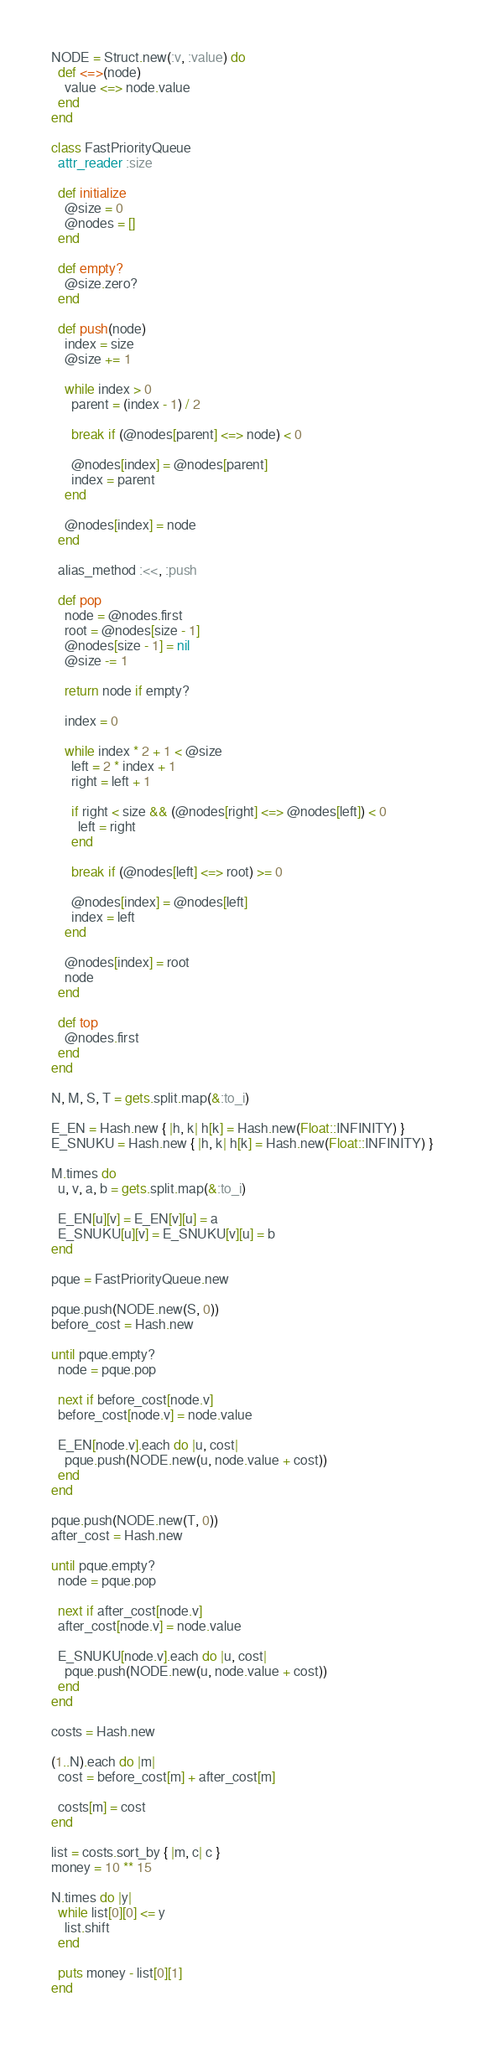<code> <loc_0><loc_0><loc_500><loc_500><_Ruby_>NODE = Struct.new(:v, :value) do
  def <=>(node)
    value <=> node.value
  end
end

class FastPriorityQueue
  attr_reader :size

  def initialize
    @size = 0
    @nodes = []
  end

  def empty?
    @size.zero?
  end

  def push(node)
    index = size
    @size += 1

    while index > 0
      parent = (index - 1) / 2

      break if (@nodes[parent] <=> node) < 0

      @nodes[index] = @nodes[parent]
      index = parent
    end

    @nodes[index] = node
  end

  alias_method :<<, :push

  def pop
    node = @nodes.first
    root = @nodes[size - 1]
    @nodes[size - 1] = nil
    @size -= 1

    return node if empty?

    index = 0

    while index * 2 + 1 < @size
      left = 2 * index + 1
      right = left + 1

      if right < size && (@nodes[right] <=> @nodes[left]) < 0
        left = right
      end

      break if (@nodes[left] <=> root) >= 0

      @nodes[index] = @nodes[left]
      index = left
    end

    @nodes[index] = root
    node
  end

  def top
    @nodes.first
  end
end

N, M, S, T = gets.split.map(&:to_i)

E_EN = Hash.new { |h, k| h[k] = Hash.new(Float::INFINITY) }
E_SNUKU = Hash.new { |h, k| h[k] = Hash.new(Float::INFINITY) }

M.times do
  u, v, a, b = gets.split.map(&:to_i)

  E_EN[u][v] = E_EN[v][u] = a
  E_SNUKU[u][v] = E_SNUKU[v][u] = b
end

pque = FastPriorityQueue.new

pque.push(NODE.new(S, 0))
before_cost = Hash.new

until pque.empty?
  node = pque.pop

  next if before_cost[node.v]
  before_cost[node.v] = node.value

  E_EN[node.v].each do |u, cost|
    pque.push(NODE.new(u, node.value + cost))
  end
end

pque.push(NODE.new(T, 0))
after_cost = Hash.new

until pque.empty?
  node = pque.pop

  next if after_cost[node.v]
  after_cost[node.v] = node.value

  E_SNUKU[node.v].each do |u, cost|
    pque.push(NODE.new(u, node.value + cost))
  end
end

costs = Hash.new

(1..N).each do |m|
  cost = before_cost[m] + after_cost[m]

  costs[m] = cost
end

list = costs.sort_by { |m, c| c }
money = 10 ** 15

N.times do |y|
  while list[0][0] <= y
    list.shift
  end

  puts money - list[0][1]
end
</code> 